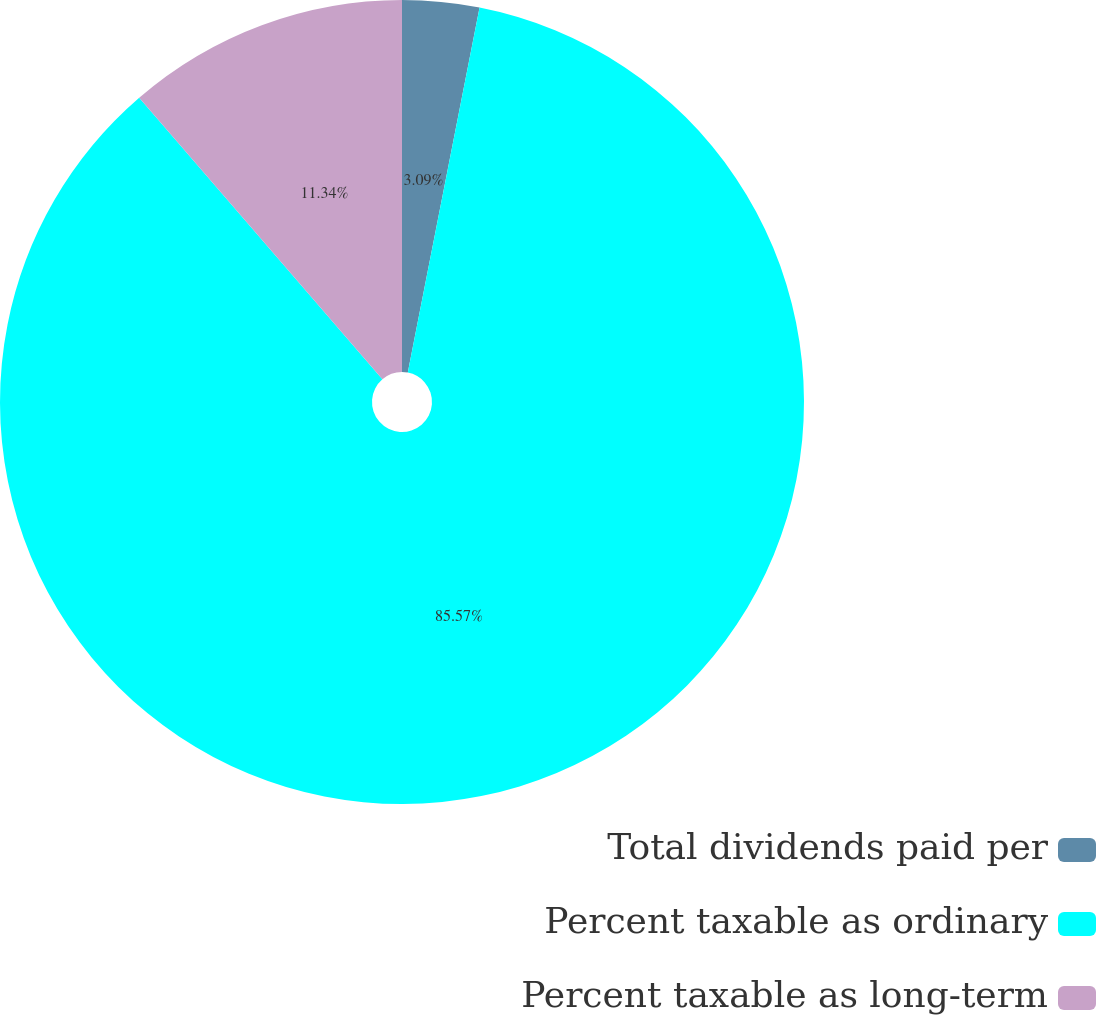<chart> <loc_0><loc_0><loc_500><loc_500><pie_chart><fcel>Total dividends paid per<fcel>Percent taxable as ordinary<fcel>Percent taxable as long-term<nl><fcel>3.09%<fcel>85.57%<fcel>11.34%<nl></chart> 